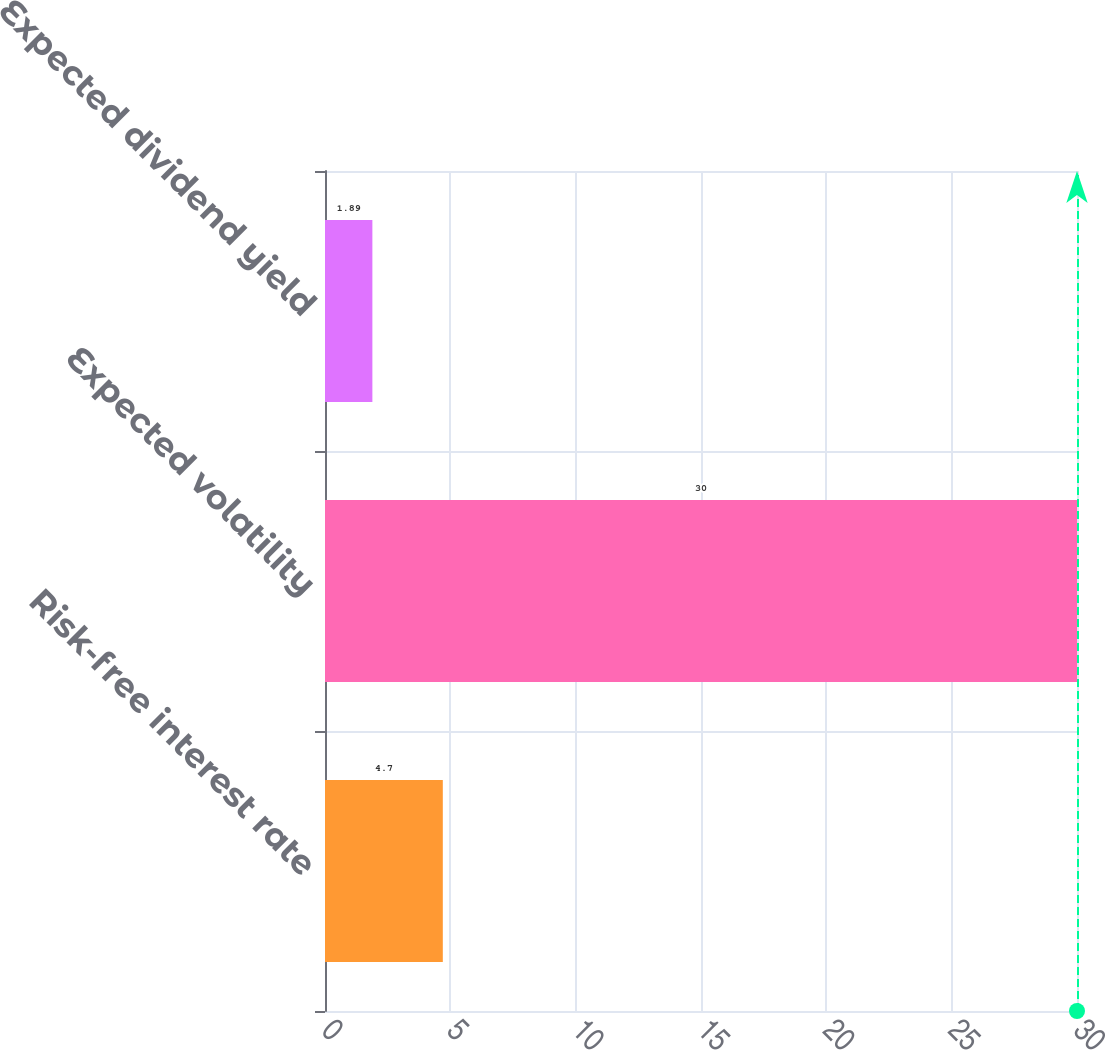Convert chart to OTSL. <chart><loc_0><loc_0><loc_500><loc_500><bar_chart><fcel>Risk-free interest rate<fcel>Expected volatility<fcel>Expected dividend yield<nl><fcel>4.7<fcel>30<fcel>1.89<nl></chart> 